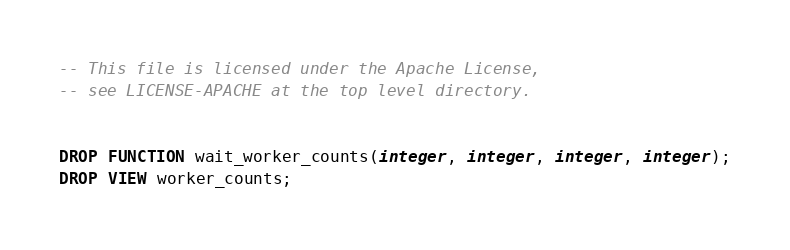Convert code to text. <code><loc_0><loc_0><loc_500><loc_500><_SQL_>-- This file is licensed under the Apache License,
-- see LICENSE-APACHE at the top level directory.


DROP FUNCTION wait_worker_counts(integer, integer, integer, integer);
DROP VIEW worker_counts;
</code> 